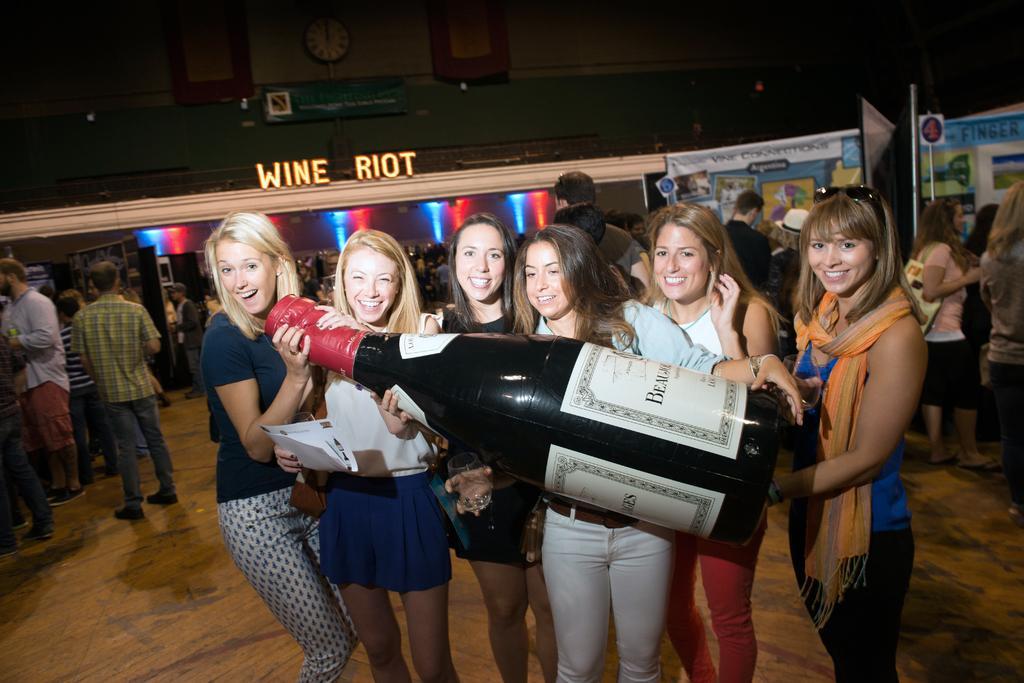Describe this image in one or two sentences. In this image, in the middle there are six women, they are smiling, they are holding a bottle. On the left there is a man, he wears a shirt, trouser, he is walking and there are people. On the right there are women and some people. In the background there are posters, boards, building, text, lights, clock and a wall. 